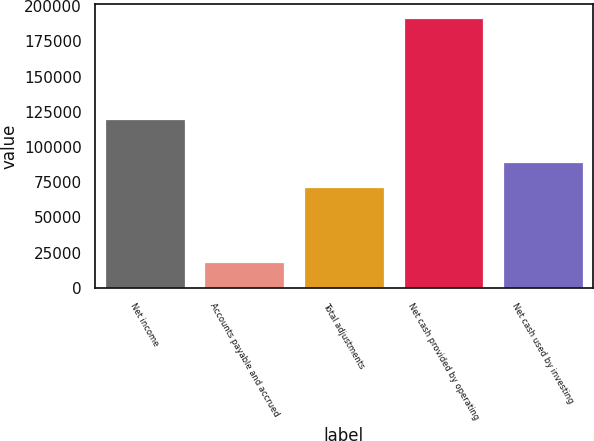Convert chart. <chart><loc_0><loc_0><loc_500><loc_500><bar_chart><fcel>Net income<fcel>Accounts payable and accrued<fcel>Total adjustments<fcel>Net cash provided by operating<fcel>Net cash used by investing<nl><fcel>120000<fcel>18575<fcel>71854<fcel>191854<fcel>89181.9<nl></chart> 